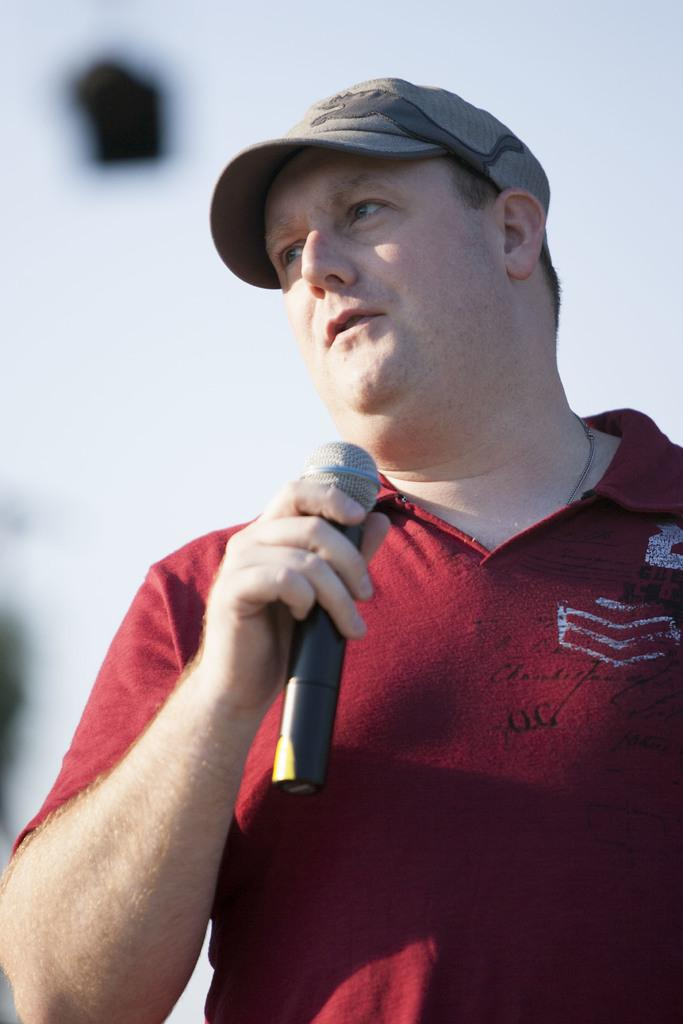What is the main subject of the image? The main subject of the image is a man. What is the man wearing on his upper body? The man is wearing a red T-shirt. What object is the man holding in his hand? The man is holding a mic in his hand. What type of headwear is the man wearing? The man is wearing a hat on his head. How would you describe the background of the image? The background of the image is blurred. What type of jeans is the man wearing in the image? The provided facts do not mention the man wearing jeans; he is wearing a red T-shirt. How many hills can be seen in the background of the image? There are no hills visible in the image; the background is blurred. 